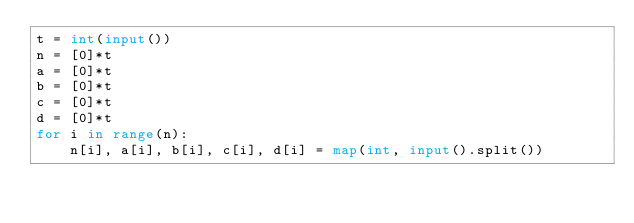<code> <loc_0><loc_0><loc_500><loc_500><_Python_>t = int(input())
n = [0]*t
a = [0]*t
b = [0]*t
c = [0]*t
d = [0]*t
for i in range(n):
    n[i], a[i], b[i], c[i], d[i] = map(int, input().split())

</code> 